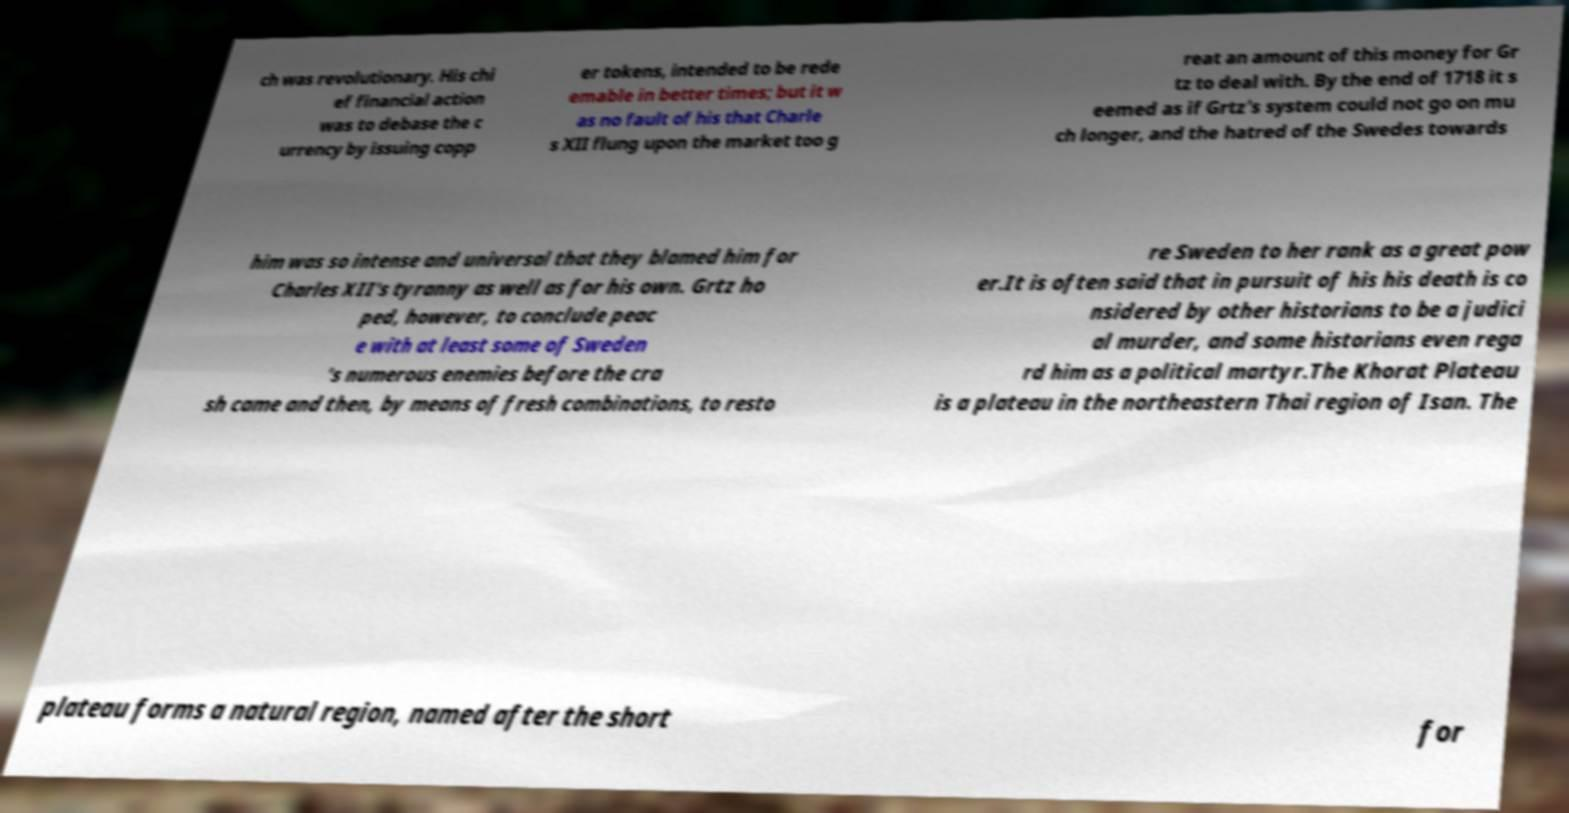I need the written content from this picture converted into text. Can you do that? ch was revolutionary. His chi ef financial action was to debase the c urrency by issuing copp er tokens, intended to be rede emable in better times; but it w as no fault of his that Charle s XII flung upon the market too g reat an amount of this money for Gr tz to deal with. By the end of 1718 it s eemed as if Grtz’s system could not go on mu ch longer, and the hatred of the Swedes towards him was so intense and universal that they blamed him for Charles XII's tyranny as well as for his own. Grtz ho ped, however, to conclude peac e with at least some of Sweden ’s numerous enemies before the cra sh came and then, by means of fresh combinations, to resto re Sweden to her rank as a great pow er.It is often said that in pursuit of his his death is co nsidered by other historians to be a judici al murder, and some historians even rega rd him as a political martyr.The Khorat Plateau is a plateau in the northeastern Thai region of Isan. The plateau forms a natural region, named after the short for 